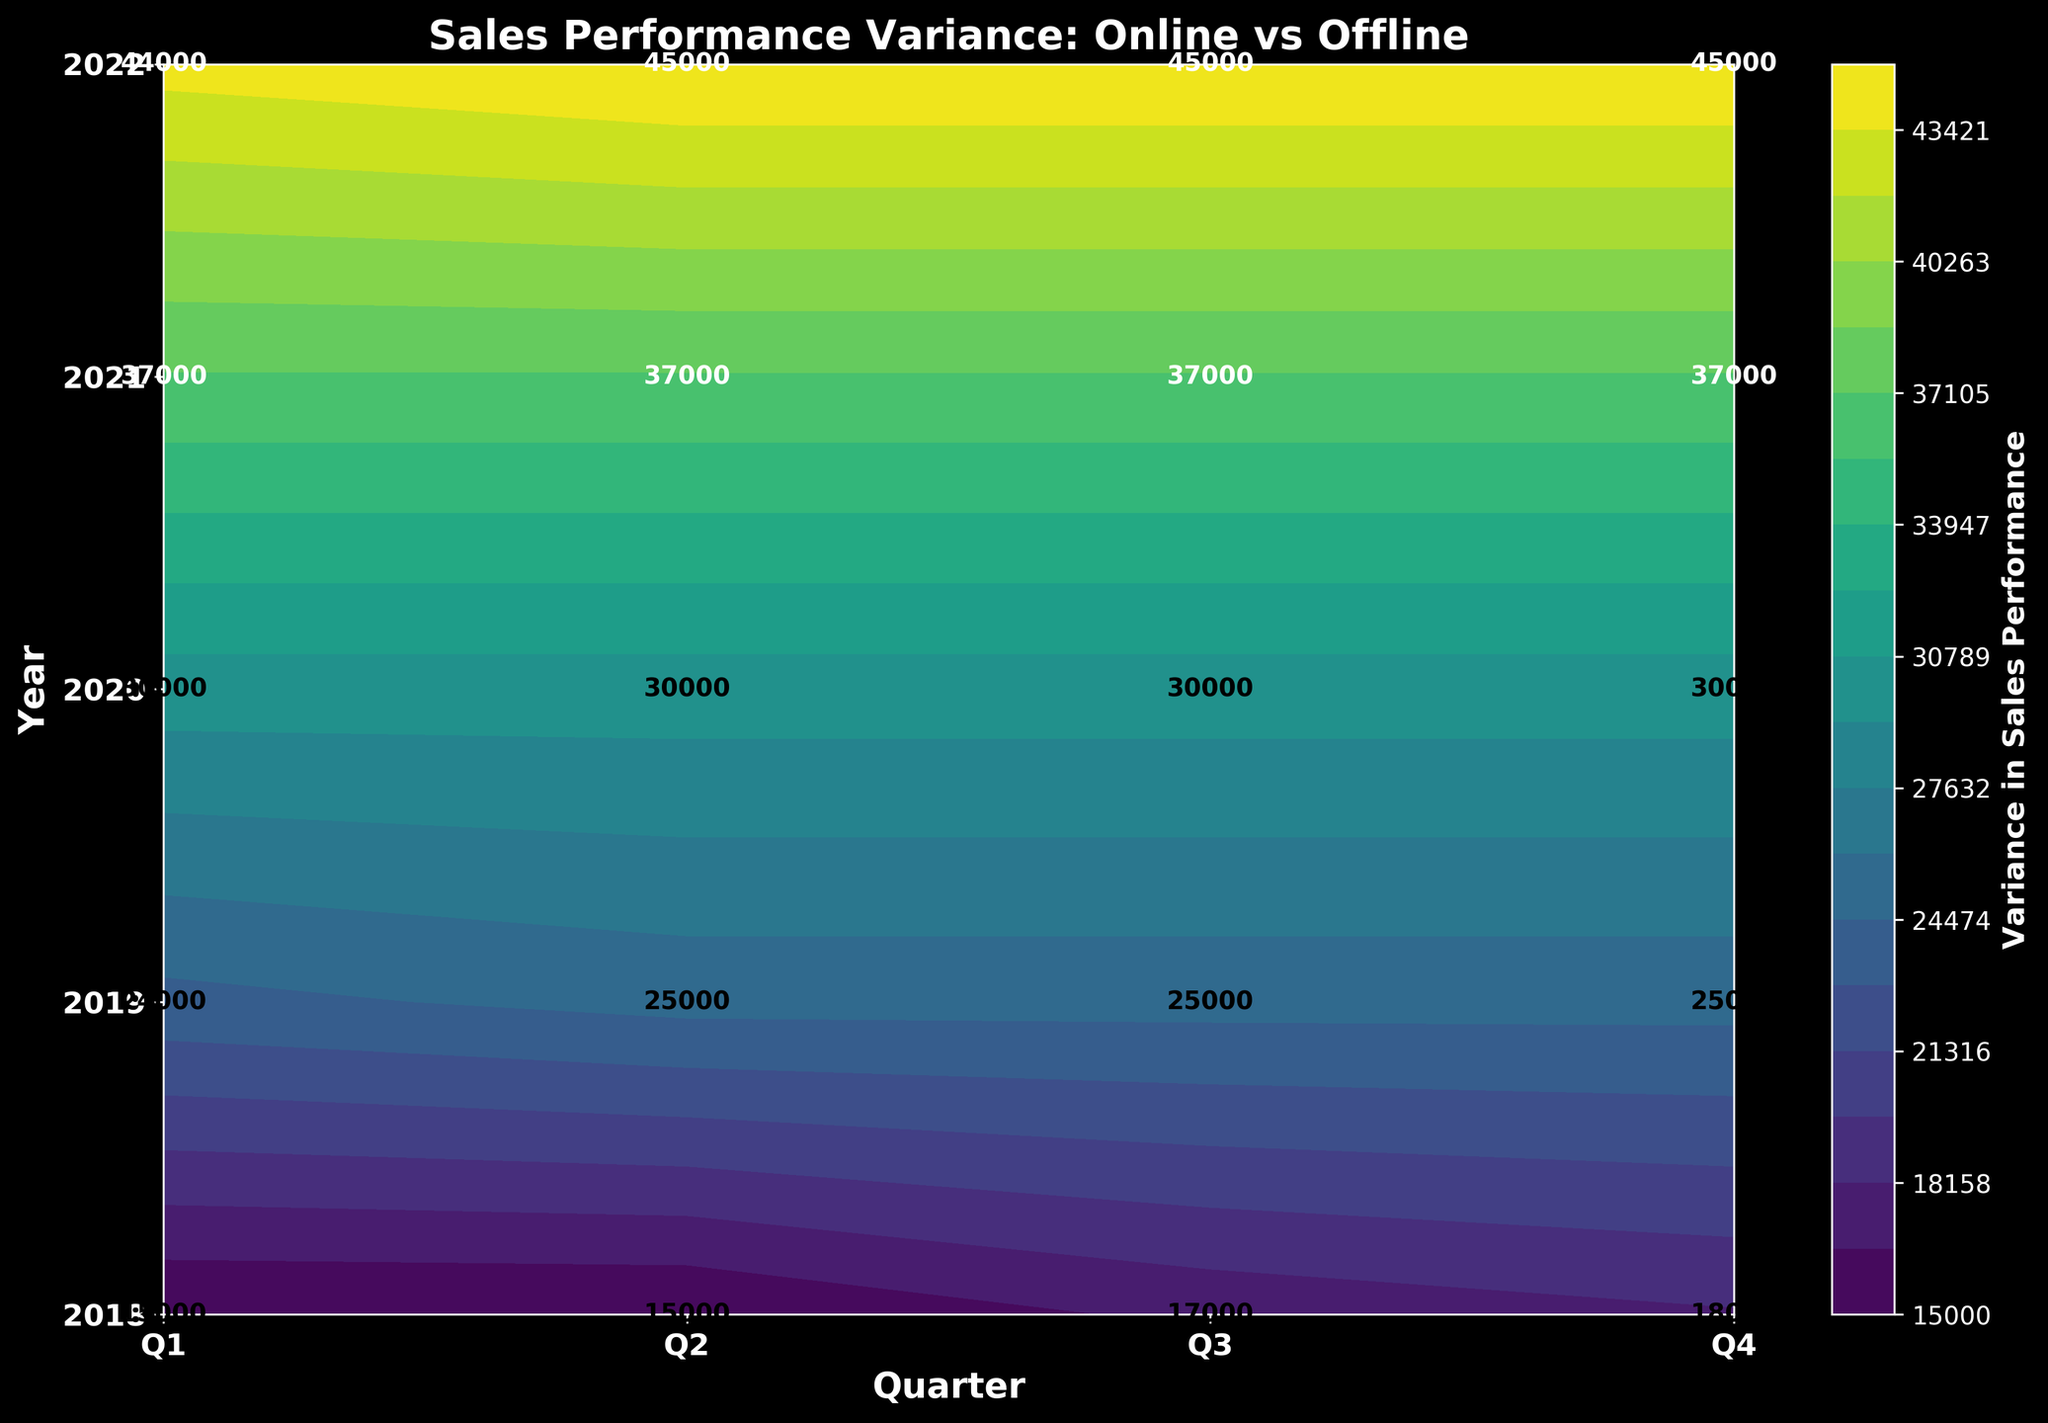What is the title of the figure? The title of the figure is prominently displayed at the top and reads "Sales Performance Variance: Online vs Offline".
Answer: Sales Performance Variance: Online vs Offline Which year shows the highest variance in Q4? Looking at the numbers in Q4 from each row corresponding to the years, the highest value equivalent to the highest variance can be observed in 2022 with a value of 45000.
Answer: 2022 What are the quarters represented on the x-axis? The x-axis labels indicate the four quarters: Q1, Q2, Q3, and Q4.
Answer: Q1, Q2, Q3, Q4 Which channel had higher sales performance overall in 2020? To determine this, observe the color scale and annotations for 2020. More positive values indicate that online sales performance was significantly higher than offline in all quarters of 2020.
Answer: Online What is the range of the variance values depicted by the contour plot? The contour plot displays a color bar indicating the range of variance values, which is between the minimum and maximum values specified by the levels of the contour. Here, it ranges from approximately 15000 to 55000.
Answer: 15000 to 55000 Which quarter had the most significant increase in variance from 2019 to 2020? Comparing quarters between 2019 and 2020, Q1 shows a sharp increase in positive variance value from 24000 in 2019 to 30000 in 2020, indicating the most significant increase.
Answer: Q1 How much did the variance in sales performance change from Q2 to Q3 in 2021? The variance in Q2 of 2021 is labeled as 37000. In Q3 of 2021, it is 37000. Hence, the change in variance from Q2 to Q3 is 0.
Answer: 0 Which quarter in 2018 had the lowest sales performance variance? By comparing the variance values for the year 2018, the quarter with the lowest variance is Q1, with a value of 15000.
Answer: Q1 Which year shows the least variance in Q2? From the contour's text annotations in Q2 over the years, 2018 shows the least variance with a value of 15000.
Answer: 2018 Is the variance generally increasing or decreasing over the years? Observing the trend of variance values over the years from 2018 to 2022, there is a gradual increase, indicated by rising values.
Answer: Increasing 